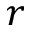<formula> <loc_0><loc_0><loc_500><loc_500>r</formula> 